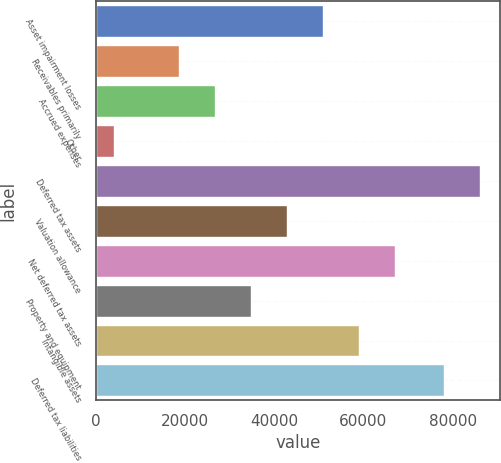Convert chart to OTSL. <chart><loc_0><loc_0><loc_500><loc_500><bar_chart><fcel>Asset impairment losses<fcel>Receivables primarily<fcel>Accrued expenses<fcel>Other<fcel>Deferred tax assets<fcel>Valuation allowance<fcel>Net deferred tax assets<fcel>Property and equipment<fcel>Intangible assets<fcel>Deferred tax liabilities<nl><fcel>50957.8<fcel>18583<fcel>26676.7<fcel>4119<fcel>86252.7<fcel>42864.1<fcel>67145.2<fcel>34770.4<fcel>59051.5<fcel>78159<nl></chart> 